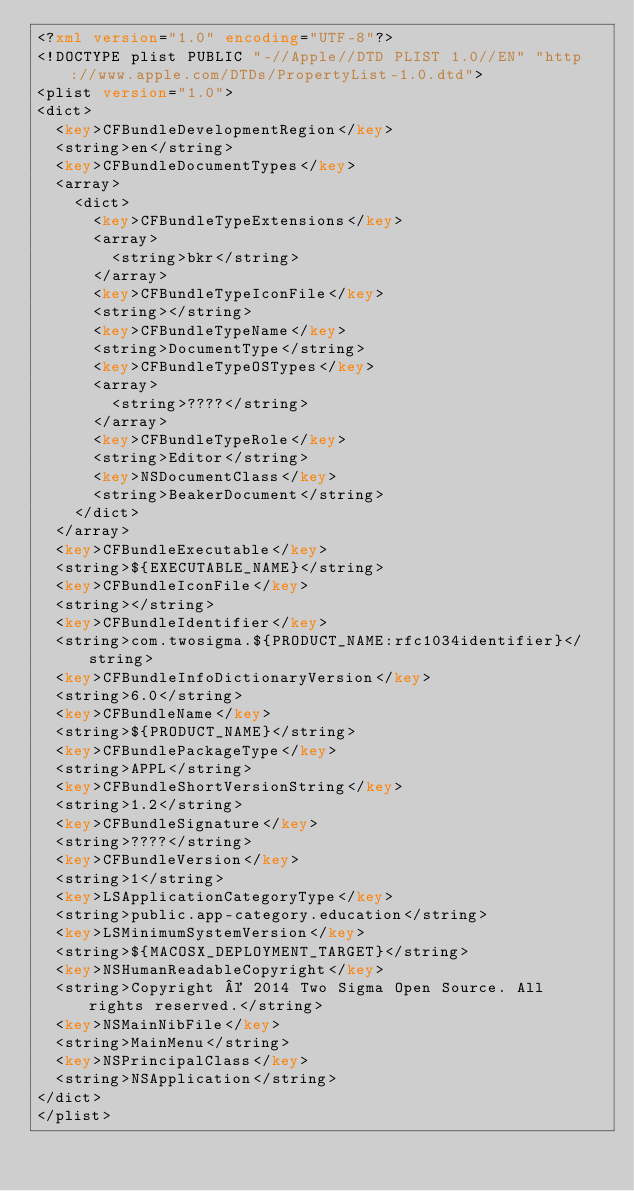<code> <loc_0><loc_0><loc_500><loc_500><_XML_><?xml version="1.0" encoding="UTF-8"?>
<!DOCTYPE plist PUBLIC "-//Apple//DTD PLIST 1.0//EN" "http://www.apple.com/DTDs/PropertyList-1.0.dtd">
<plist version="1.0">
<dict>
	<key>CFBundleDevelopmentRegion</key>
	<string>en</string>
	<key>CFBundleDocumentTypes</key>
	<array>
		<dict>
			<key>CFBundleTypeExtensions</key>
			<array>
				<string>bkr</string>
			</array>
			<key>CFBundleTypeIconFile</key>
			<string></string>
			<key>CFBundleTypeName</key>
			<string>DocumentType</string>
			<key>CFBundleTypeOSTypes</key>
			<array>
				<string>????</string>
			</array>
			<key>CFBundleTypeRole</key>
			<string>Editor</string>
			<key>NSDocumentClass</key>
			<string>BeakerDocument</string>
		</dict>
	</array>
	<key>CFBundleExecutable</key>
	<string>${EXECUTABLE_NAME}</string>
	<key>CFBundleIconFile</key>
	<string></string>
	<key>CFBundleIdentifier</key>
	<string>com.twosigma.${PRODUCT_NAME:rfc1034identifier}</string>
	<key>CFBundleInfoDictionaryVersion</key>
	<string>6.0</string>
	<key>CFBundleName</key>
	<string>${PRODUCT_NAME}</string>
	<key>CFBundlePackageType</key>
	<string>APPL</string>
	<key>CFBundleShortVersionString</key>
	<string>1.2</string>
	<key>CFBundleSignature</key>
	<string>????</string>
	<key>CFBundleVersion</key>
	<string>1</string>
	<key>LSApplicationCategoryType</key>
	<string>public.app-category.education</string>
	<key>LSMinimumSystemVersion</key>
	<string>${MACOSX_DEPLOYMENT_TARGET}</string>
	<key>NSHumanReadableCopyright</key>
	<string>Copyright © 2014 Two Sigma Open Source. All rights reserved.</string>
	<key>NSMainNibFile</key>
	<string>MainMenu</string>
	<key>NSPrincipalClass</key>
	<string>NSApplication</string>
</dict>
</plist>
</code> 